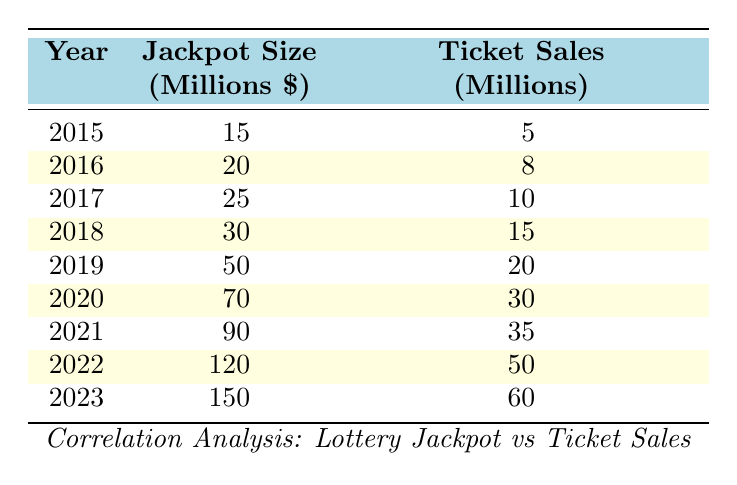What was the jackpot size in 2019? The table shows that in the year 2019, the jackpot size was listed as 50 million dollars.
Answer: 50 million How many ticket sales were there in 2021? According to the table, the ticket sales in the year 2021 amounted to 35 million.
Answer: 35 million What was the average jackpot size from 2015 to 2023? To find the average jackpot size, sum the jackpot sizes from each year (15 + 20 + 25 + 30 + 50 + 70 + 90 + 120 + 150 = 570) and divide by the number of years (9). The average is 570 / 9 ≈ 63.33 million.
Answer: Approximately 63.33 million Did the ticket sales increase every year from 2015 to 2023? By examining each year in the table, it shows a continuous increase in ticket sales from 5 million in 2015 to 60 million in 2023, confirming that ticket sales increased each year.
Answer: Yes What is the difference between the jackpot size in 2023 and the jackpot size in 2015? The jackpot size in 2023 is 150 million and in 2015 it was 15 million. The difference is calculated as 150 - 15 = 135 million.
Answer: 135 million What year had the lowest ticket sales compared to the jackpot size? By evaluating the table, the year 2015 had the lowest ticket sales of 5 million and a jackpot size of 15 million, showing the lowest relative ticket sales.
Answer: 2015 Is the correlation between jackpot size and ticket sales positive according to the table? Observing the table, as the jackpot size increases, the ticket sales also consistently increase, which indicates a positive correlation.
Answer: Yes How much did ticket sales increase from 2021 to 2022? The ticket sales in 2021 were 35 million, and in 2022, they rose to 50 million. The increase can be calculated as 50 - 35 = 15 million.
Answer: 15 million What is the total jackpot size for the years when ticket sales were over 30 million? The years with ticket sales over 30 million are 2020, 2021, 2022, and 2023; their jackpot sizes are 70, 90, 120, and 150 million respectively. The total is calculated as (70 + 90 + 120 + 150 = 430) million.
Answer: 430 million 